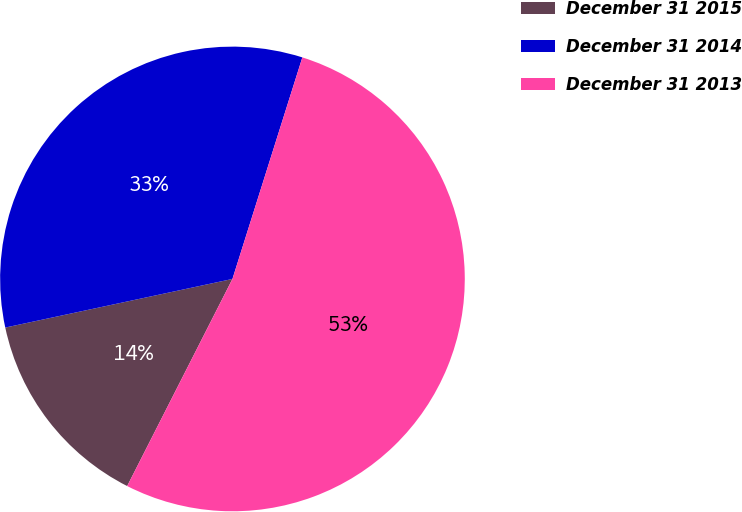Convert chart. <chart><loc_0><loc_0><loc_500><loc_500><pie_chart><fcel>December 31 2015<fcel>December 31 2014<fcel>December 31 2013<nl><fcel>14.16%<fcel>33.22%<fcel>52.62%<nl></chart> 